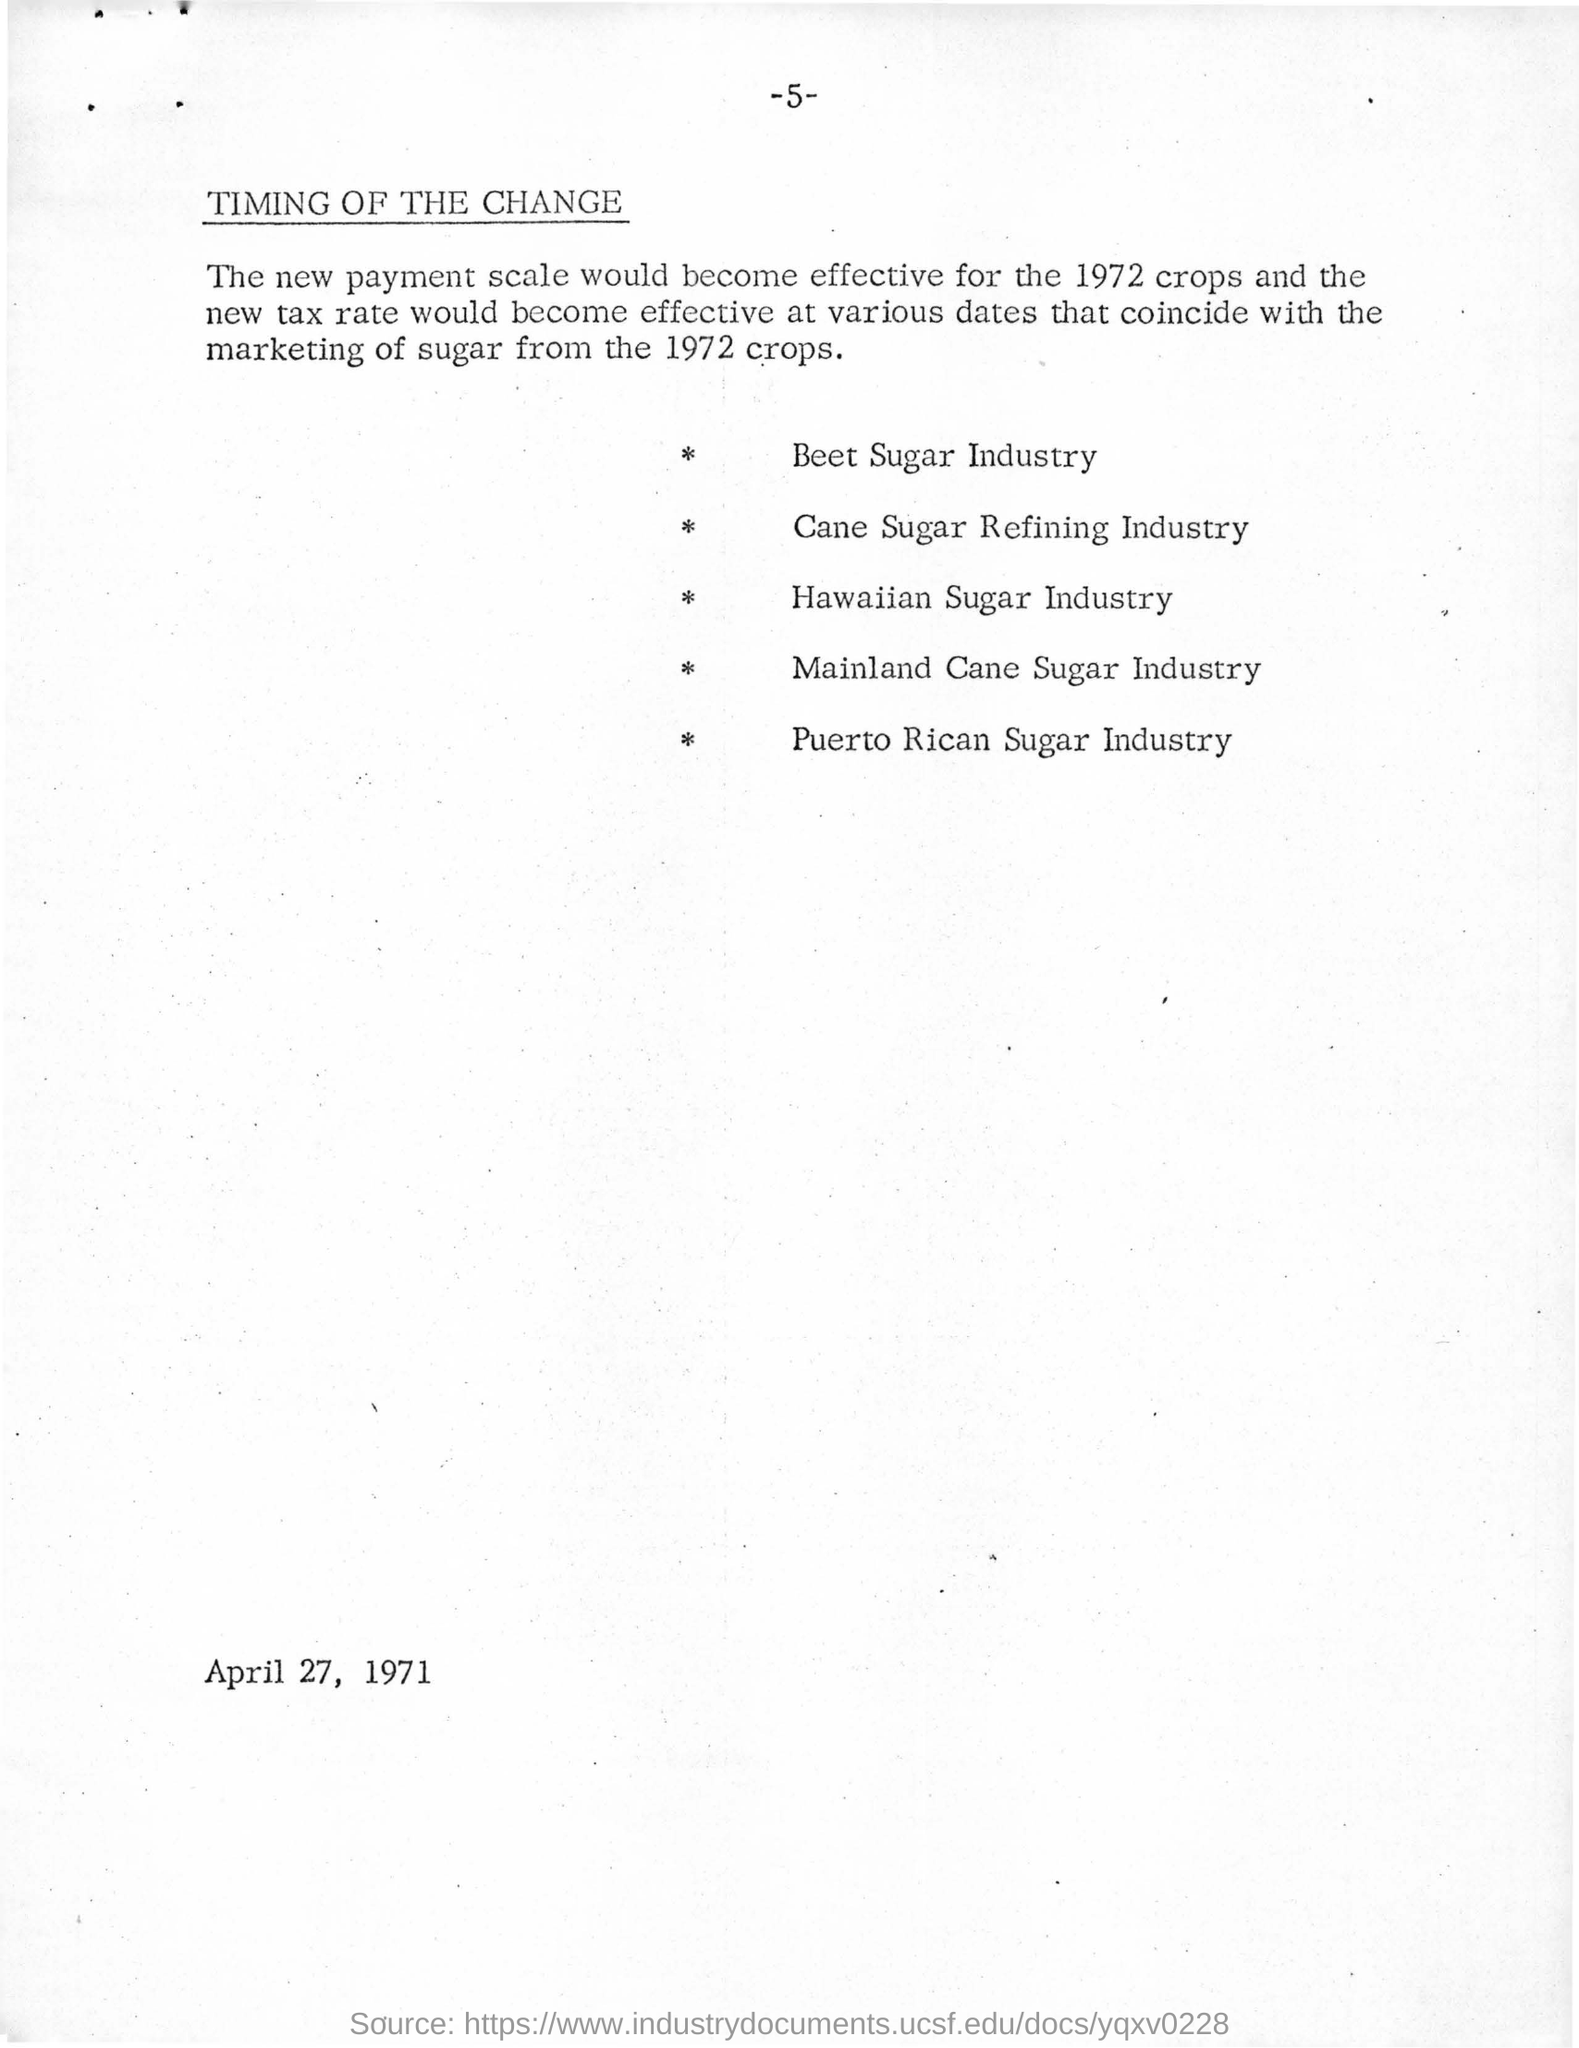What is the page no mentioned in this document?
Offer a terse response. -5-. What is the date mentioned in this document?
Offer a very short reply. April 27, 1971. 